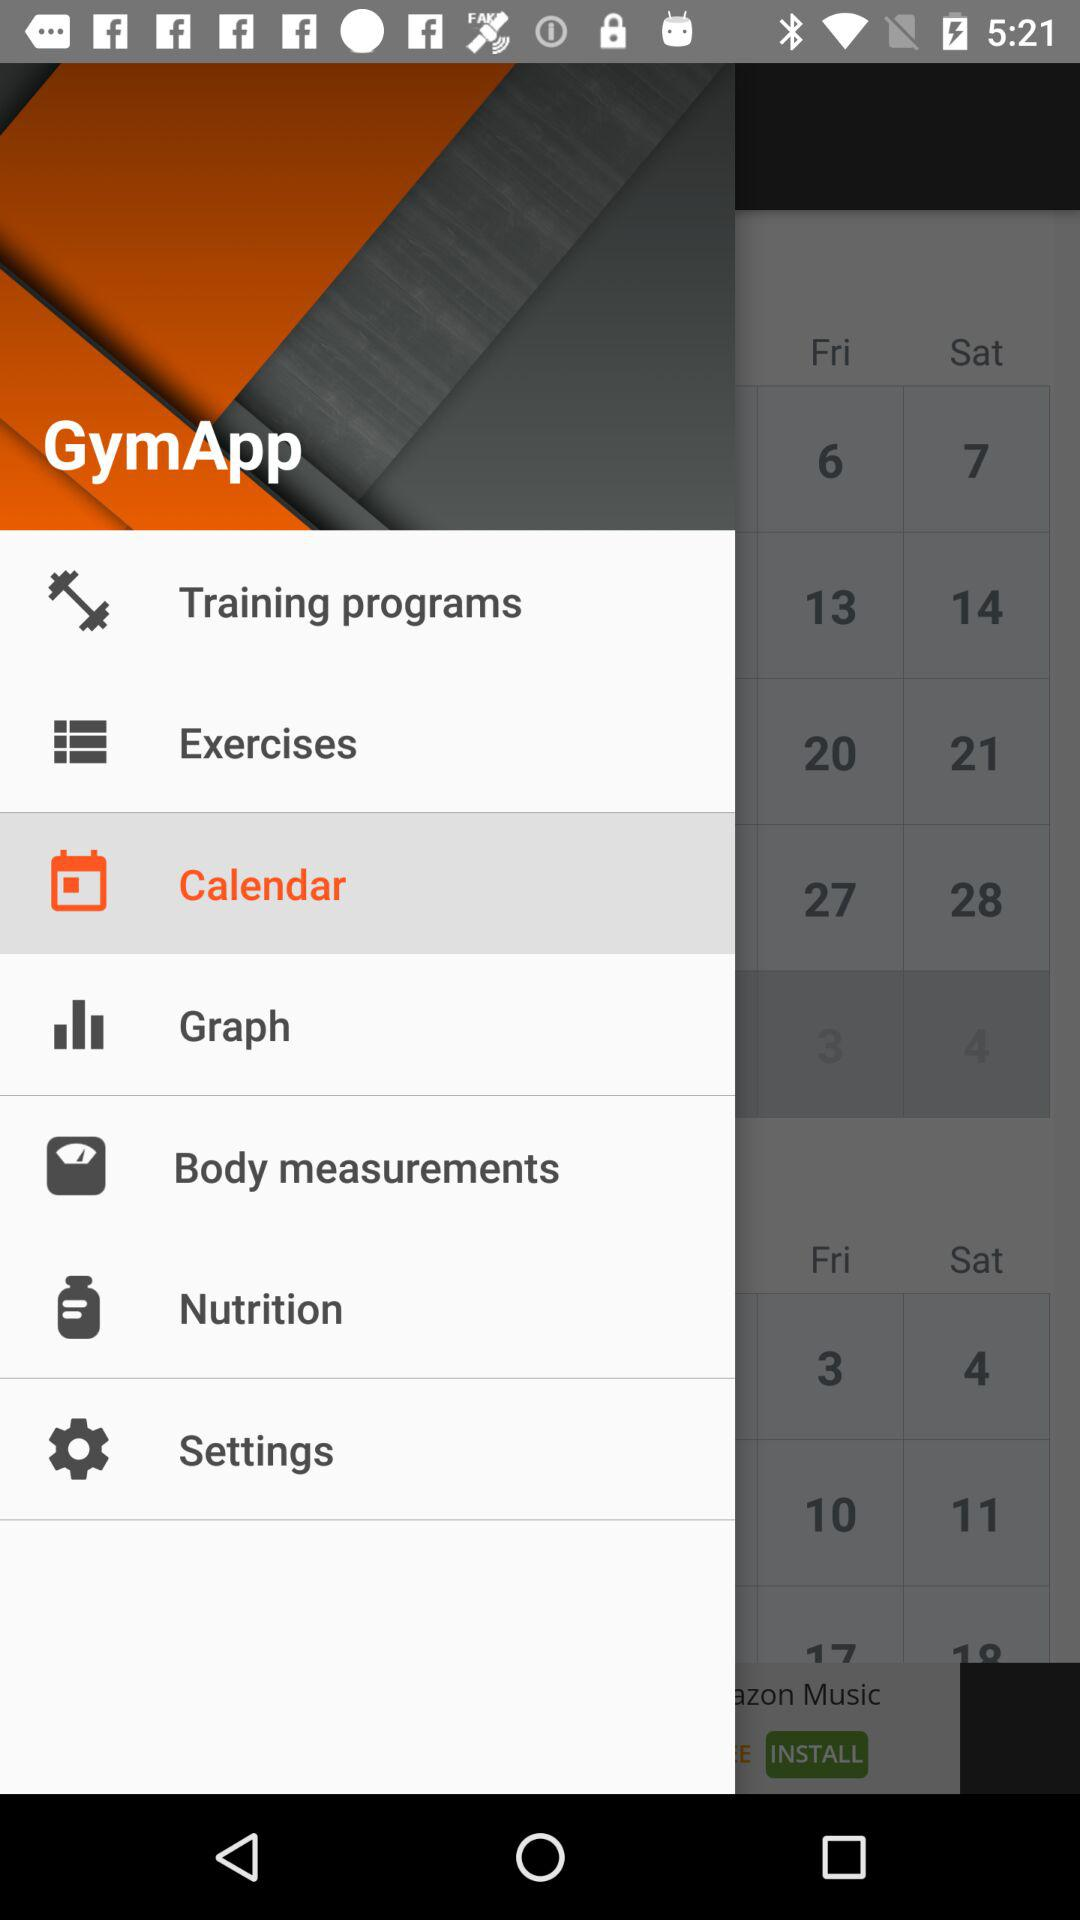Which item is selected? The selected item is "Calendar". 